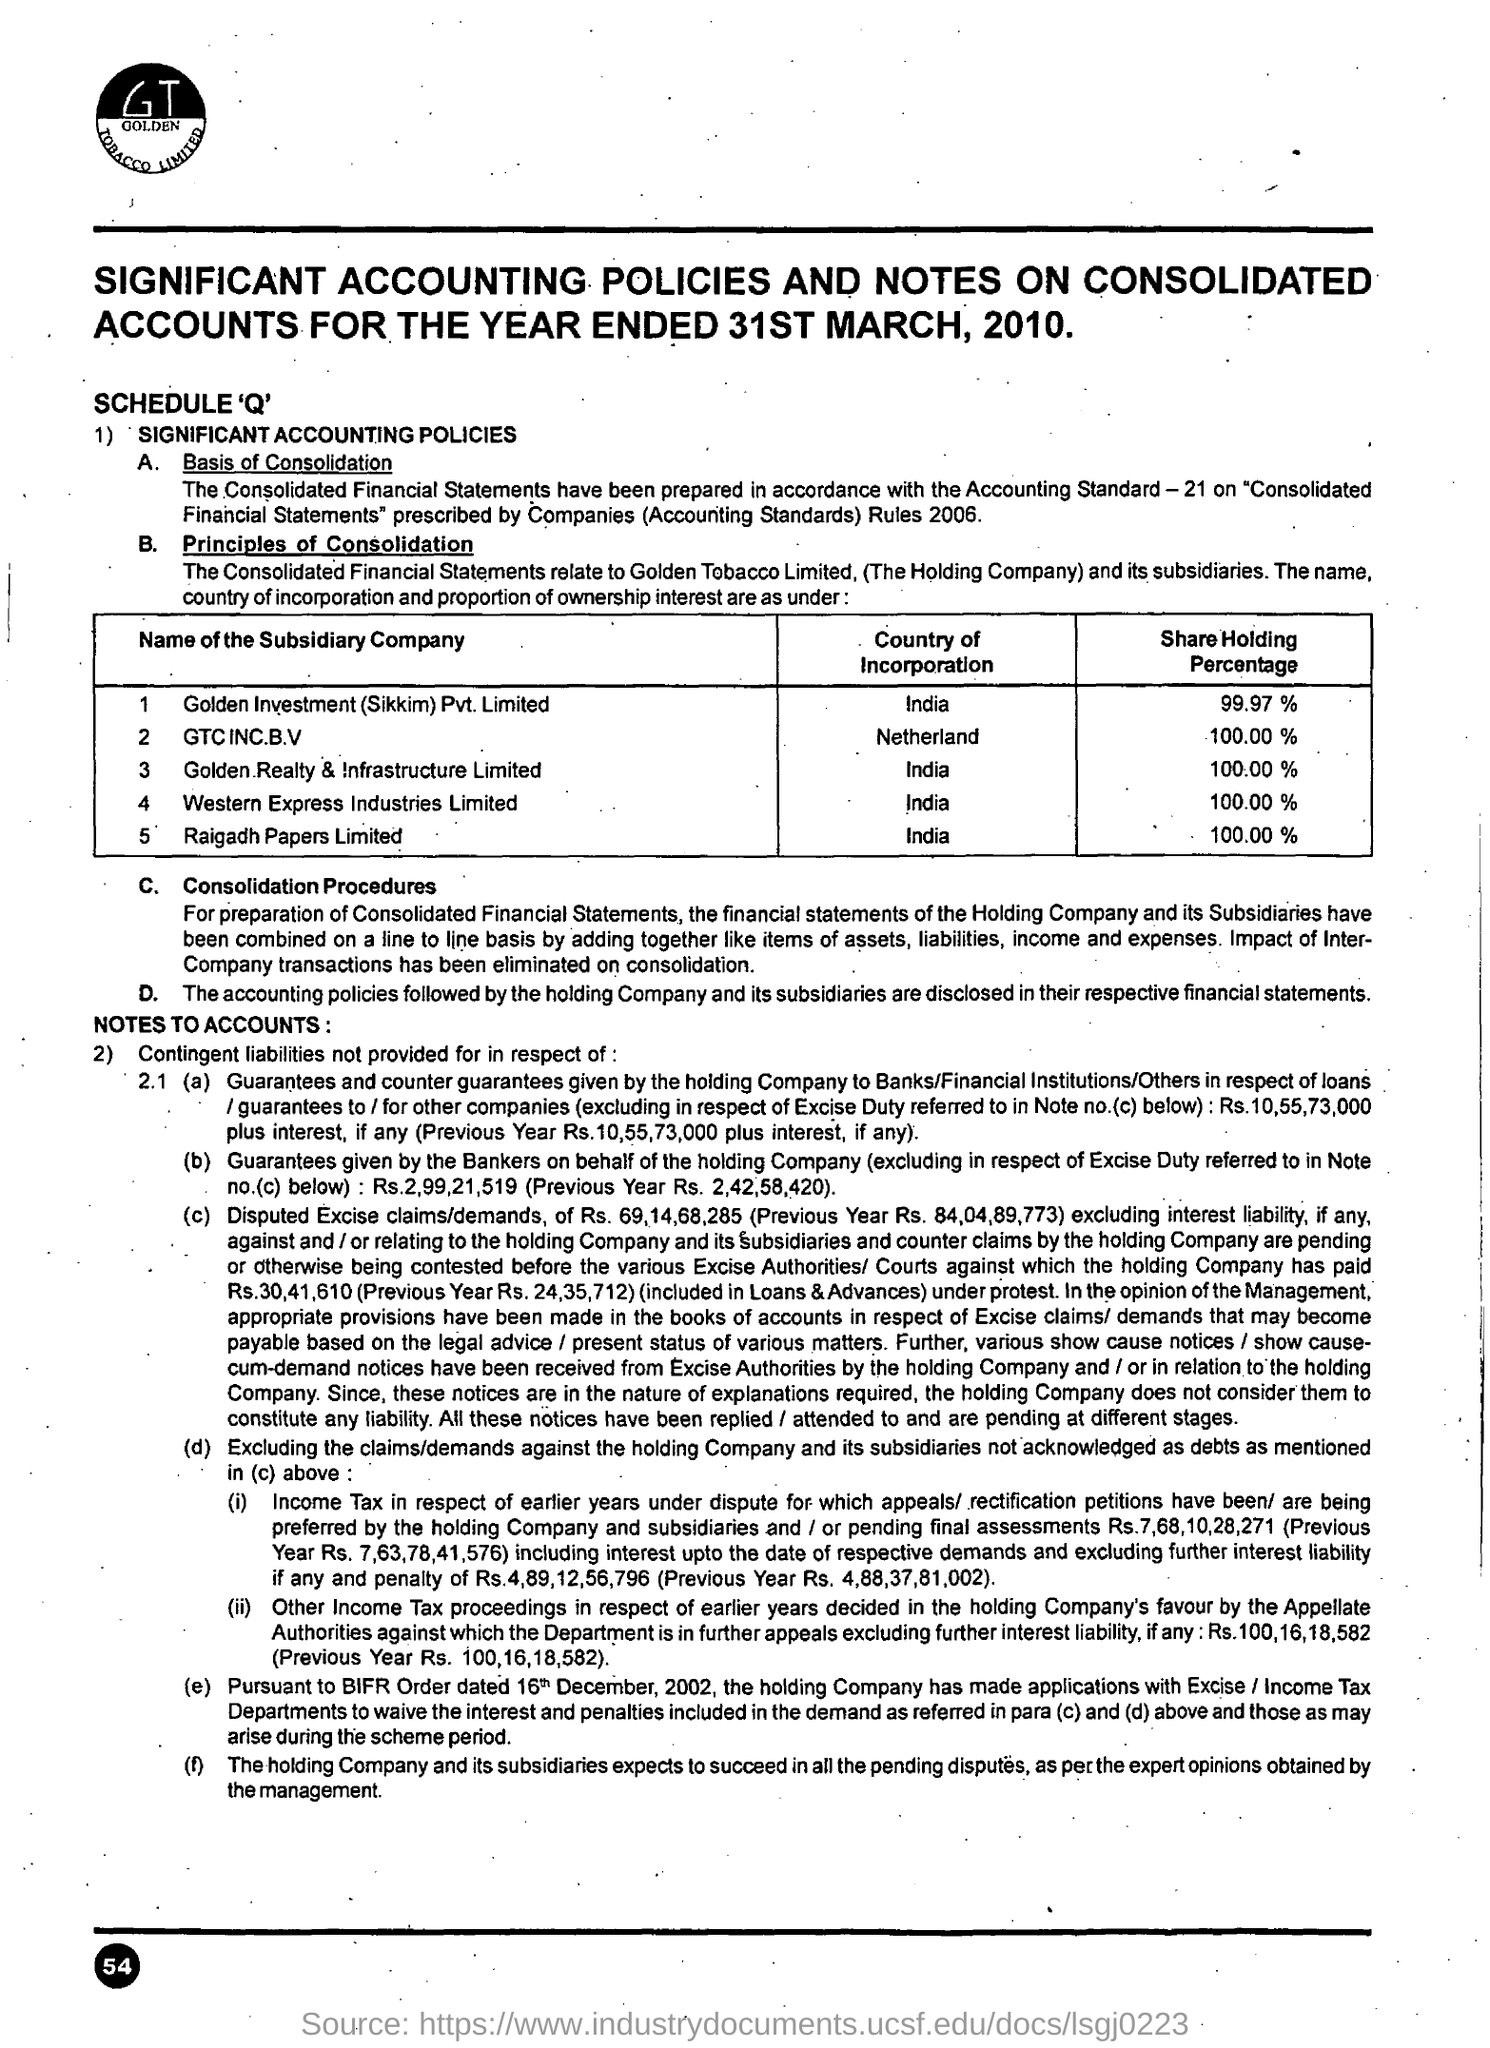Mention a couple of crucial points in this snapshot. GC INC B.V is incorporated in the Netherlands. 